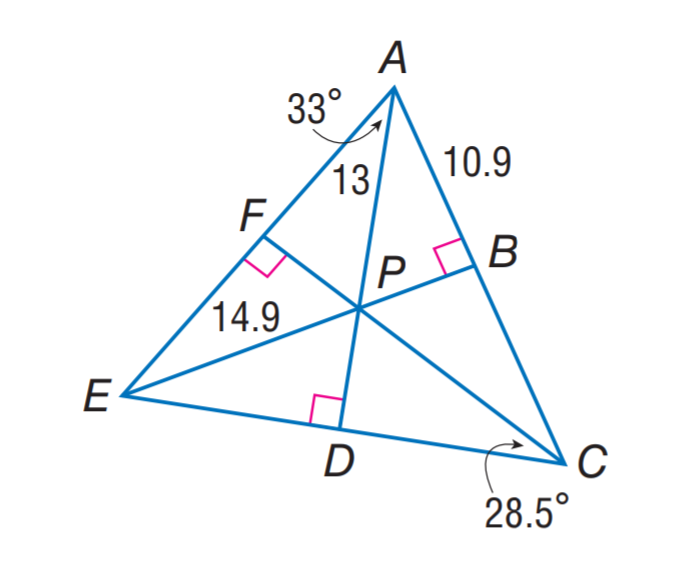Answer the mathemtical geometry problem and directly provide the correct option letter.
Question: P is the incenter of \triangle A E C. Find m \angle D A C.
Choices: A: 28.5 B: 30 C: 31 D: 33 D 